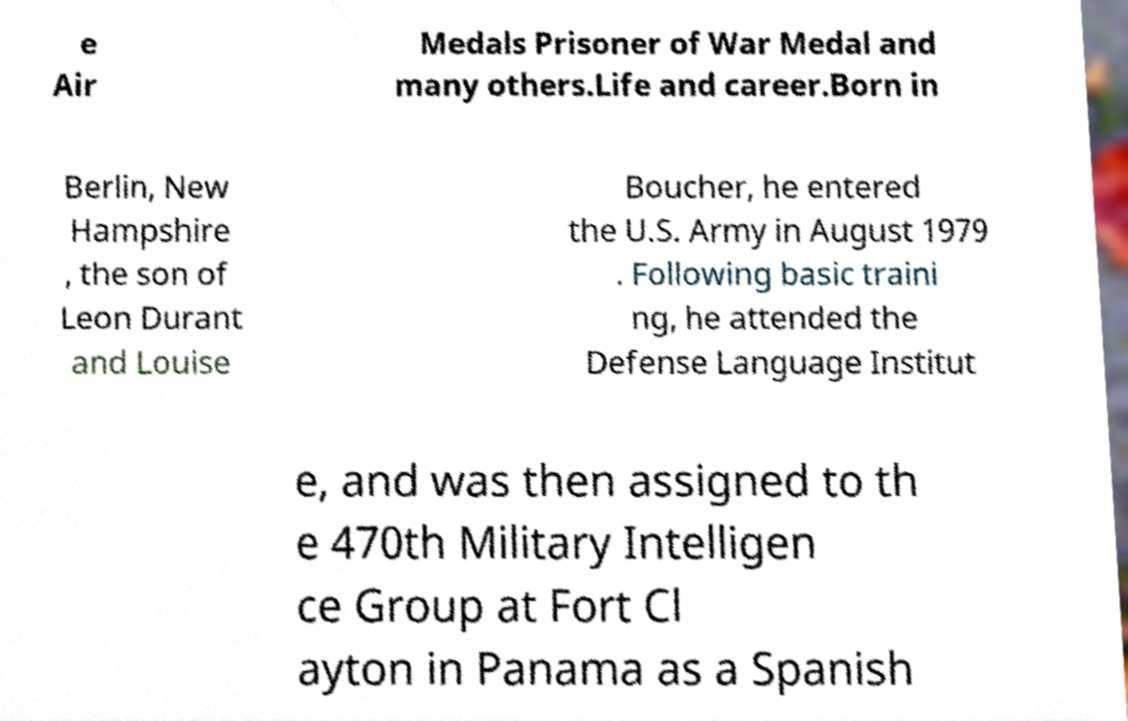Please identify and transcribe the text found in this image. e Air Medals Prisoner of War Medal and many others.Life and career.Born in Berlin, New Hampshire , the son of Leon Durant and Louise Boucher, he entered the U.S. Army in August 1979 . Following basic traini ng, he attended the Defense Language Institut e, and was then assigned to th e 470th Military Intelligen ce Group at Fort Cl ayton in Panama as a Spanish 